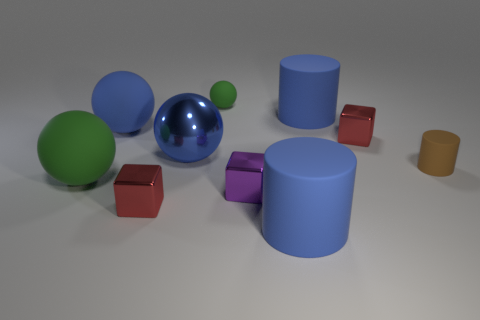The tiny red cube in front of the tiny red metallic block on the right side of the big cylinder that is behind the brown rubber cylinder is made of what material?
Offer a terse response. Metal. Are there more green spheres that are on the left side of the tiny ball than brown objects that are in front of the brown matte cylinder?
Make the answer very short. Yes. How many cylinders are big blue shiny things or green matte things?
Offer a terse response. 0. There is a tiny matte thing that is on the left side of the red metal thing that is on the right side of the big blue shiny ball; how many big green matte balls are right of it?
Your answer should be very brief. 0. There is another sphere that is the same color as the big metallic sphere; what is it made of?
Provide a succinct answer. Rubber. Are there more red objects than tiny cubes?
Provide a short and direct response. No. Is the size of the purple shiny thing the same as the brown matte cylinder?
Offer a very short reply. Yes. What number of objects are big brown objects or tiny purple objects?
Offer a terse response. 1. The tiny shiny thing that is right of the big matte cylinder that is in front of the big blue thing to the left of the blue shiny ball is what shape?
Your answer should be very brief. Cube. Do the tiny red object that is on the left side of the small purple thing and the tiny red object that is behind the brown thing have the same material?
Offer a terse response. Yes. 